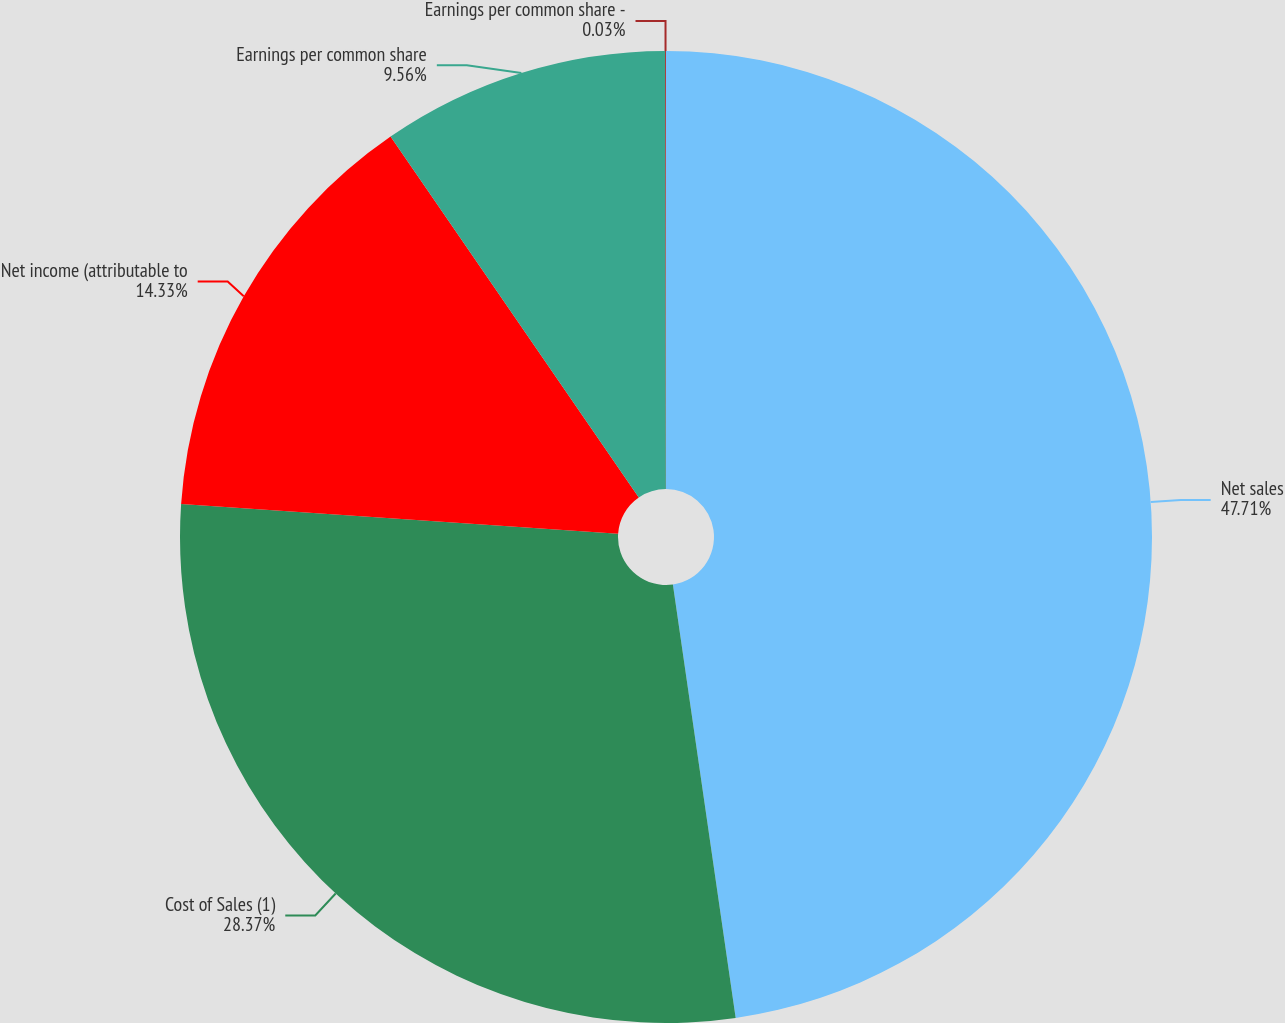Convert chart. <chart><loc_0><loc_0><loc_500><loc_500><pie_chart><fcel>Net sales<fcel>Cost of Sales (1)<fcel>Net income (attributable to<fcel>Earnings per common share<fcel>Earnings per common share -<nl><fcel>47.71%<fcel>28.37%<fcel>14.33%<fcel>9.56%<fcel>0.03%<nl></chart> 